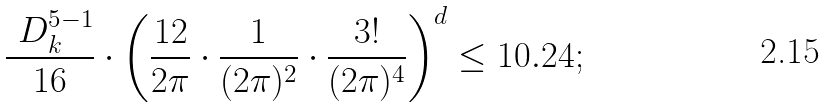Convert formula to latex. <formula><loc_0><loc_0><loc_500><loc_500>\frac { \ D _ { k } ^ { 5 - 1 } } { 1 6 } \cdot \left ( \frac { 1 2 } { 2 \pi } \cdot \frac { 1 } { ( 2 \pi ) ^ { 2 } } \cdot \frac { 3 ! } { ( 2 \pi ) ^ { 4 } } \right ) ^ { d } \leq 1 0 . 2 4 ;</formula> 